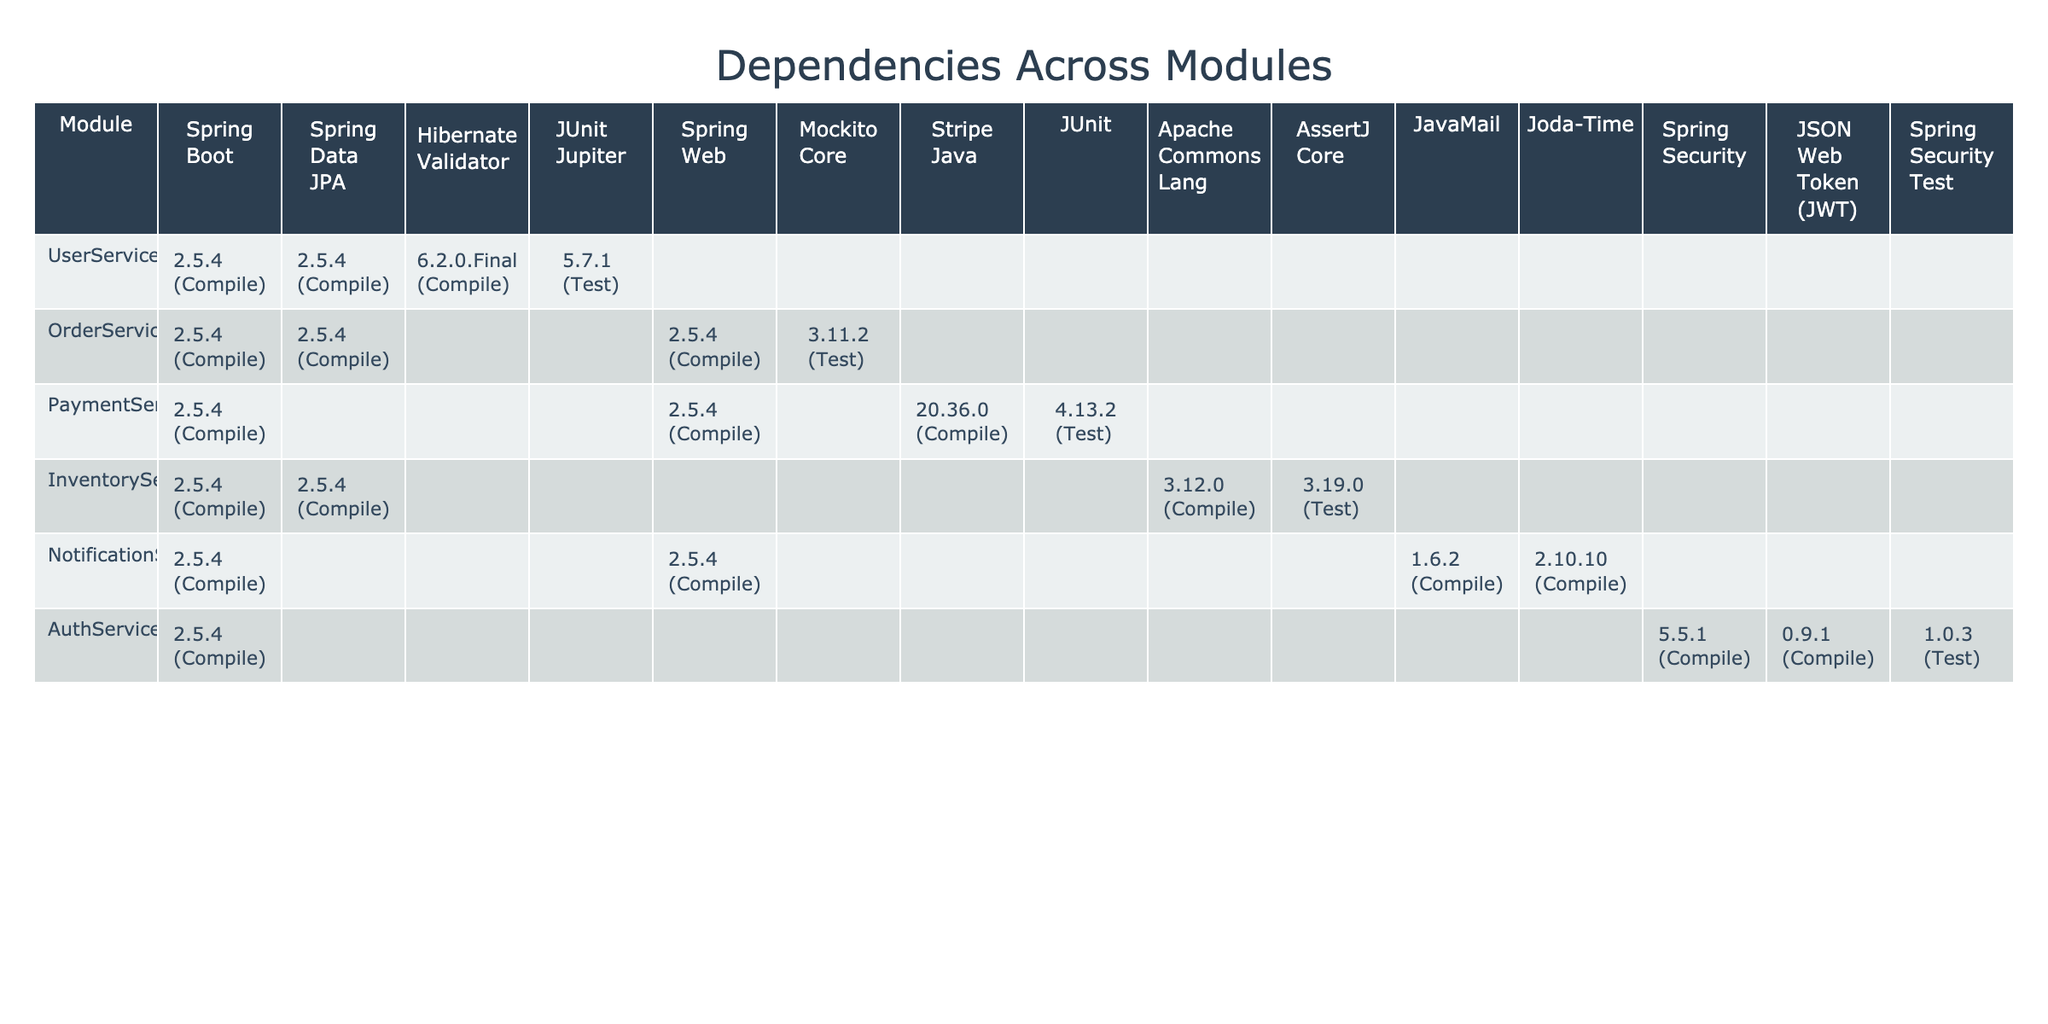What dependencies are used in the UserService module? The table shows that the dependencies for the UserService module are: Spring Boot (2.5.4, Compile), Spring Data JPA (2.5.4, Compile), Hibernate Validator (6.2.0.Final, Compile), and JUnit Jupiter (5.7.1, Test).
Answer: Spring Boot, Spring Data JPA, Hibernate Validator, JUnit Jupiter How many compile dependencies does the PaymentService module have? The dependencies for PaymentService are: Spring Boot (2.5.4, Compile), Spring Web (2.5.4, Compile), and Stripe Java (20.36.0, Compile). Counting these, there are three compile dependencies.
Answer: 3 Is JUnit used as a dependency in any module? JUnit is listed in the UserService as JUnit Jupiter (5.7.1, Test) and in the PaymentService as JUnit (4.13.2, Test), indicating its use in both modules.
Answer: Yes Which module uses the highest number of unique dependencies? After examining each module, the most dependencies are associated with the AuthService, which has 4 unique dependencies: Spring Security (5.5.1, Compile), Spring Boot (2.5.4, Compile), JSON Web Token (JWT) (0.9.1, Compile), and Spring Security Test (1.0.3, Test).
Answer: AuthService What is the version of Spring Data JPA used across all modules? In all modules, the version of Spring Data JPA used is consistently 2.5.4 for UserService, OrderService, and InventoryService, which indicates no variation across these modules.
Answer: 2.5.4 Does the NotificationService module have any test dependencies? The table shows that the NotificationService does not list any test dependencies, indicating there are none associated.
Answer: No What is the scope of the Hibernate Validator dependency in the UserService module? The table states that the Hibernate Validator is a compile dependency in the UserService module, indicating it's required for compiling.
Answer: Compile Which service includes the Stripe Java dependency? The Stripe Java dependency is included in the PaymentService module as shown in the table.
Answer: PaymentService How many total unique dependencies across all modules are in the table? By reviewing all listed dependencies, we identify a total of 12 unique dependencies across the modules.
Answer: 12 Is there a difference in the version of Spring Boot used in AuthService and other services? No, the version of Spring Boot used in AuthService (2.5.4) is the same as in UserService, OrderService, PaymentService, and NotificationService, indicating consistency.
Answer: No difference Which module has the oldest version of a dependency listed? The oldest version seen in the table is for JSON Web Token (JWT) at version 0.9.1 used in AuthService, while others are more recent.
Answer: AuthService (JSON Web Token) 